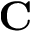<formula> <loc_0><loc_0><loc_500><loc_500>C</formula> 